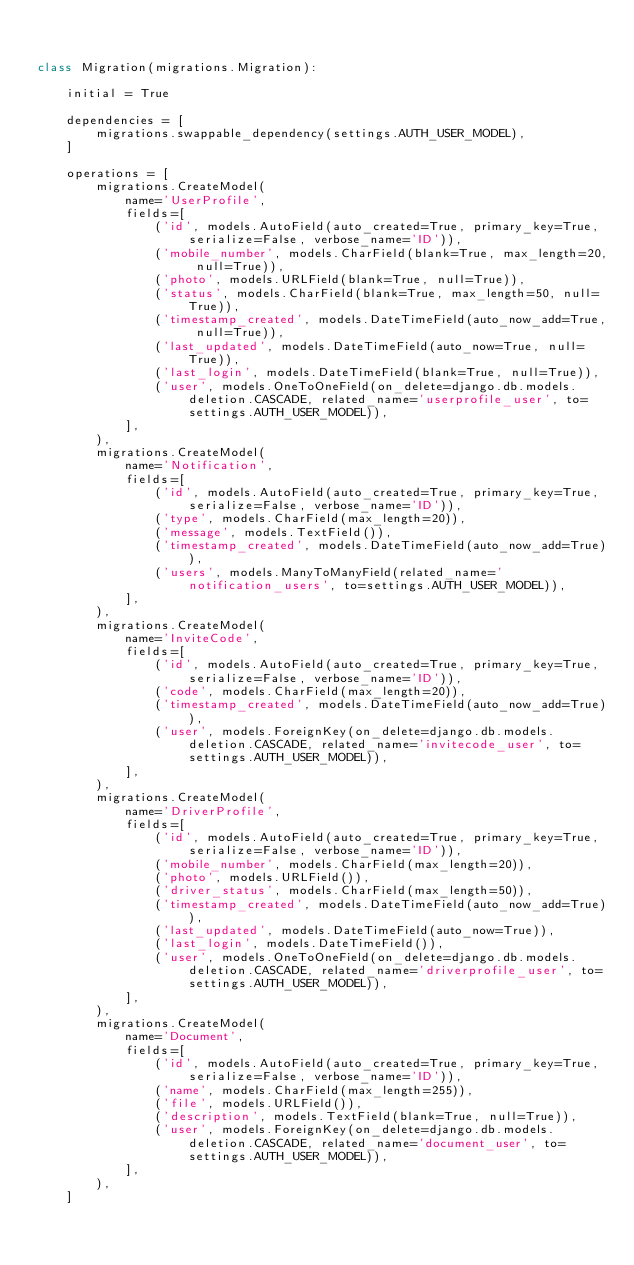Convert code to text. <code><loc_0><loc_0><loc_500><loc_500><_Python_>

class Migration(migrations.Migration):

    initial = True

    dependencies = [
        migrations.swappable_dependency(settings.AUTH_USER_MODEL),
    ]

    operations = [
        migrations.CreateModel(
            name='UserProfile',
            fields=[
                ('id', models.AutoField(auto_created=True, primary_key=True, serialize=False, verbose_name='ID')),
                ('mobile_number', models.CharField(blank=True, max_length=20, null=True)),
                ('photo', models.URLField(blank=True, null=True)),
                ('status', models.CharField(blank=True, max_length=50, null=True)),
                ('timestamp_created', models.DateTimeField(auto_now_add=True, null=True)),
                ('last_updated', models.DateTimeField(auto_now=True, null=True)),
                ('last_login', models.DateTimeField(blank=True, null=True)),
                ('user', models.OneToOneField(on_delete=django.db.models.deletion.CASCADE, related_name='userprofile_user', to=settings.AUTH_USER_MODEL)),
            ],
        ),
        migrations.CreateModel(
            name='Notification',
            fields=[
                ('id', models.AutoField(auto_created=True, primary_key=True, serialize=False, verbose_name='ID')),
                ('type', models.CharField(max_length=20)),
                ('message', models.TextField()),
                ('timestamp_created', models.DateTimeField(auto_now_add=True)),
                ('users', models.ManyToManyField(related_name='notification_users', to=settings.AUTH_USER_MODEL)),
            ],
        ),
        migrations.CreateModel(
            name='InviteCode',
            fields=[
                ('id', models.AutoField(auto_created=True, primary_key=True, serialize=False, verbose_name='ID')),
                ('code', models.CharField(max_length=20)),
                ('timestamp_created', models.DateTimeField(auto_now_add=True)),
                ('user', models.ForeignKey(on_delete=django.db.models.deletion.CASCADE, related_name='invitecode_user', to=settings.AUTH_USER_MODEL)),
            ],
        ),
        migrations.CreateModel(
            name='DriverProfile',
            fields=[
                ('id', models.AutoField(auto_created=True, primary_key=True, serialize=False, verbose_name='ID')),
                ('mobile_number', models.CharField(max_length=20)),
                ('photo', models.URLField()),
                ('driver_status', models.CharField(max_length=50)),
                ('timestamp_created', models.DateTimeField(auto_now_add=True)),
                ('last_updated', models.DateTimeField(auto_now=True)),
                ('last_login', models.DateTimeField()),
                ('user', models.OneToOneField(on_delete=django.db.models.deletion.CASCADE, related_name='driverprofile_user', to=settings.AUTH_USER_MODEL)),
            ],
        ),
        migrations.CreateModel(
            name='Document',
            fields=[
                ('id', models.AutoField(auto_created=True, primary_key=True, serialize=False, verbose_name='ID')),
                ('name', models.CharField(max_length=255)),
                ('file', models.URLField()),
                ('description', models.TextField(blank=True, null=True)),
                ('user', models.ForeignKey(on_delete=django.db.models.deletion.CASCADE, related_name='document_user', to=settings.AUTH_USER_MODEL)),
            ],
        ),
    ]
</code> 